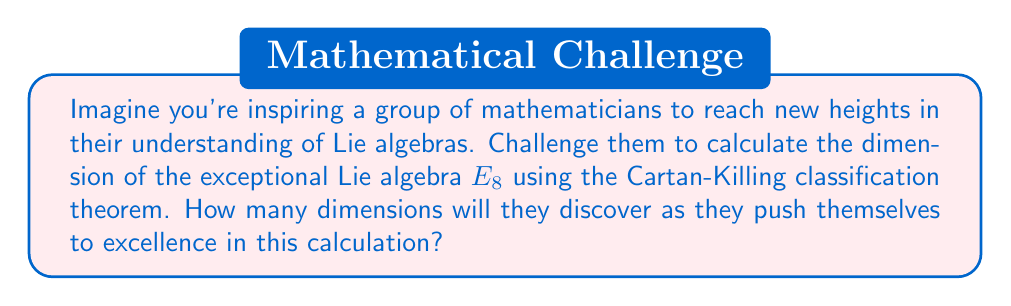Could you help me with this problem? To calculate the dimension of the exceptional Lie algebra $E_8$, we'll use the Cartan-Killing classification theorem and follow these steps:

1) The Cartan-Killing classification theorem states that every simple Lie algebra over an algebraically closed field of characteristic zero is isomorphic to one of the classical Lie algebras ($A_n$, $B_n$, $C_n$, $D_n$) or one of the exceptional Lie algebras ($G_2$, $F_4$, $E_6$, $E_7$, $E_8$).

2) For $E_8$, we need to use its Dynkin diagram:

[asy]
unitsize(1cm);
for(int i=0; i<7; ++i) {
  dot((i,0));
  draw((i,0)--(i+1,0));
}
dot((3,1));
draw((3,0)--(3,1));
dot((7,0));
label("$E_8$", (3.5,-0.5));
[/asy]

3) From the Dynkin diagram, we can see that the rank of $E_8$ is 8 (the number of nodes).

4) For exceptional Lie algebras, we can use the formula:

   $$\dim(G) = \text{rank}(G) + |\Phi^+|$$

   where $|\Phi^+|$ is the number of positive roots.

5) For $E_8$, the number of positive roots is given by:

   $$|\Phi^+| = \frac{h \cdot \text{rank}(G)}{2}$$

   where $h$ is the Coxeter number.

6) For $E_8$, the Coxeter number $h = 30$.

7) Substituting these values:

   $$\dim(E_8) = 8 + \frac{30 \cdot 8}{2} = 8 + 120 = 128$$

Therefore, as they strive for excellence in their calculations, the mathematicians will discover that the dimension of the exceptional Lie algebra $E_8$ is 128.
Answer: The dimension of the exceptional Lie algebra $E_8$ is 128. 